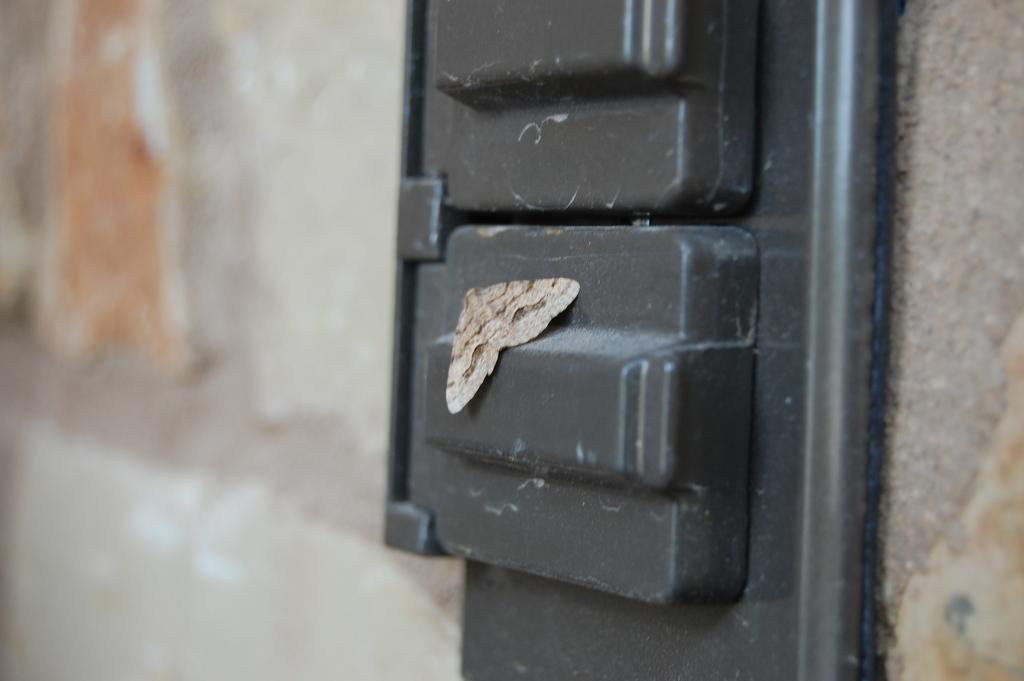What is present in the image? There is a fly in the image. What is the fly doing in the image? The fly is laying on a black-colored object. Where is your aunt's knee in the image? There is no mention of an aunt or a knee in the image; it only features a fly laying on a black-colored object. 